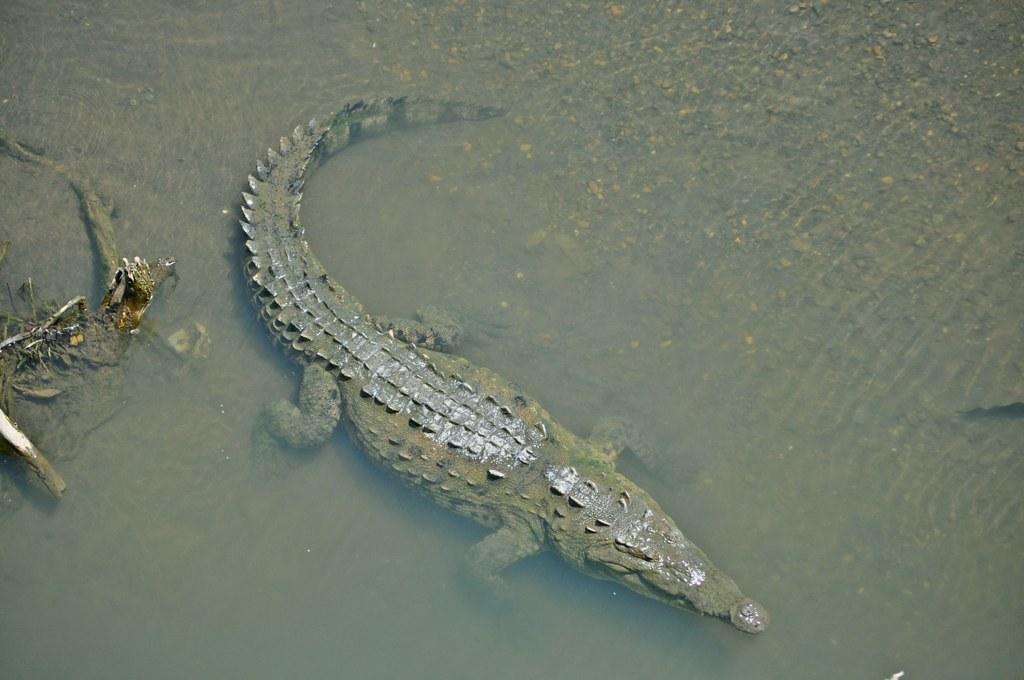Please provide a concise description of this image. It is a crocodile in the water. 